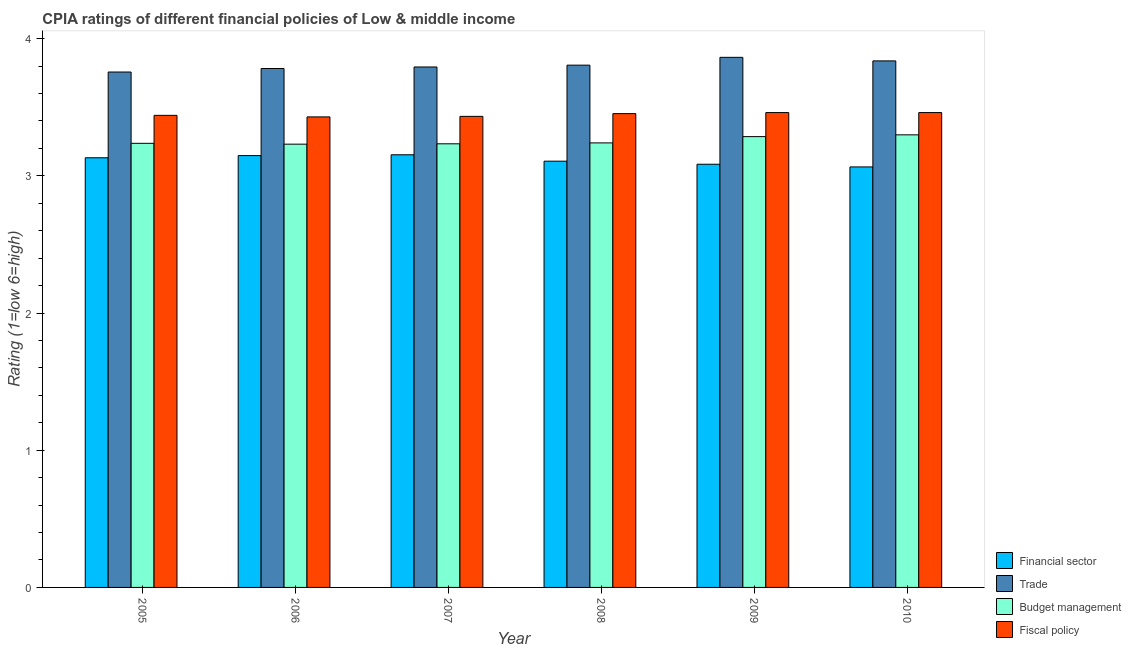How many groups of bars are there?
Keep it short and to the point. 6. How many bars are there on the 6th tick from the right?
Ensure brevity in your answer.  4. What is the cpia rating of fiscal policy in 2005?
Keep it short and to the point. 3.44. Across all years, what is the maximum cpia rating of trade?
Offer a terse response. 3.86. Across all years, what is the minimum cpia rating of budget management?
Keep it short and to the point. 3.23. In which year was the cpia rating of financial sector maximum?
Give a very brief answer. 2007. What is the total cpia rating of trade in the graph?
Your response must be concise. 22.84. What is the difference between the cpia rating of trade in 2005 and that in 2006?
Give a very brief answer. -0.03. What is the difference between the cpia rating of financial sector in 2005 and the cpia rating of trade in 2009?
Offer a terse response. 0.05. What is the average cpia rating of fiscal policy per year?
Give a very brief answer. 3.45. In how many years, is the cpia rating of fiscal policy greater than 0.8?
Give a very brief answer. 6. What is the ratio of the cpia rating of financial sector in 2005 to that in 2009?
Ensure brevity in your answer.  1.02. What is the difference between the highest and the second highest cpia rating of trade?
Your response must be concise. 0.03. What is the difference between the highest and the lowest cpia rating of trade?
Make the answer very short. 0.11. In how many years, is the cpia rating of financial sector greater than the average cpia rating of financial sector taken over all years?
Provide a short and direct response. 3. What does the 3rd bar from the left in 2008 represents?
Ensure brevity in your answer.  Budget management. What does the 2nd bar from the right in 2010 represents?
Your response must be concise. Budget management. Is it the case that in every year, the sum of the cpia rating of financial sector and cpia rating of trade is greater than the cpia rating of budget management?
Your answer should be compact. Yes. What is the difference between two consecutive major ticks on the Y-axis?
Offer a very short reply. 1. Are the values on the major ticks of Y-axis written in scientific E-notation?
Your answer should be very brief. No. Does the graph contain grids?
Give a very brief answer. No. Where does the legend appear in the graph?
Offer a very short reply. Bottom right. How many legend labels are there?
Your response must be concise. 4. What is the title of the graph?
Keep it short and to the point. CPIA ratings of different financial policies of Low & middle income. Does "Norway" appear as one of the legend labels in the graph?
Give a very brief answer. No. What is the Rating (1=low 6=high) in Financial sector in 2005?
Make the answer very short. 3.13. What is the Rating (1=low 6=high) in Trade in 2005?
Provide a succinct answer. 3.76. What is the Rating (1=low 6=high) of Budget management in 2005?
Keep it short and to the point. 3.24. What is the Rating (1=low 6=high) in Fiscal policy in 2005?
Give a very brief answer. 3.44. What is the Rating (1=low 6=high) of Financial sector in 2006?
Keep it short and to the point. 3.15. What is the Rating (1=low 6=high) in Trade in 2006?
Provide a short and direct response. 3.78. What is the Rating (1=low 6=high) in Budget management in 2006?
Provide a succinct answer. 3.23. What is the Rating (1=low 6=high) of Fiscal policy in 2006?
Ensure brevity in your answer.  3.43. What is the Rating (1=low 6=high) in Financial sector in 2007?
Provide a succinct answer. 3.15. What is the Rating (1=low 6=high) of Trade in 2007?
Keep it short and to the point. 3.79. What is the Rating (1=low 6=high) of Budget management in 2007?
Your answer should be compact. 3.23. What is the Rating (1=low 6=high) in Fiscal policy in 2007?
Offer a very short reply. 3.43. What is the Rating (1=low 6=high) in Financial sector in 2008?
Provide a succinct answer. 3.11. What is the Rating (1=low 6=high) in Trade in 2008?
Your answer should be compact. 3.81. What is the Rating (1=low 6=high) of Budget management in 2008?
Keep it short and to the point. 3.24. What is the Rating (1=low 6=high) of Fiscal policy in 2008?
Make the answer very short. 3.45. What is the Rating (1=low 6=high) of Financial sector in 2009?
Provide a succinct answer. 3.08. What is the Rating (1=low 6=high) in Trade in 2009?
Offer a very short reply. 3.86. What is the Rating (1=low 6=high) in Budget management in 2009?
Provide a succinct answer. 3.29. What is the Rating (1=low 6=high) of Fiscal policy in 2009?
Offer a very short reply. 3.46. What is the Rating (1=low 6=high) of Financial sector in 2010?
Ensure brevity in your answer.  3.06. What is the Rating (1=low 6=high) in Trade in 2010?
Offer a terse response. 3.84. What is the Rating (1=low 6=high) of Budget management in 2010?
Offer a very short reply. 3.3. What is the Rating (1=low 6=high) of Fiscal policy in 2010?
Ensure brevity in your answer.  3.46. Across all years, what is the maximum Rating (1=low 6=high) in Financial sector?
Make the answer very short. 3.15. Across all years, what is the maximum Rating (1=low 6=high) of Trade?
Give a very brief answer. 3.86. Across all years, what is the maximum Rating (1=low 6=high) of Budget management?
Keep it short and to the point. 3.3. Across all years, what is the maximum Rating (1=low 6=high) in Fiscal policy?
Provide a succinct answer. 3.46. Across all years, what is the minimum Rating (1=low 6=high) in Financial sector?
Give a very brief answer. 3.06. Across all years, what is the minimum Rating (1=low 6=high) in Trade?
Provide a short and direct response. 3.76. Across all years, what is the minimum Rating (1=low 6=high) of Budget management?
Provide a short and direct response. 3.23. Across all years, what is the minimum Rating (1=low 6=high) in Fiscal policy?
Your answer should be compact. 3.43. What is the total Rating (1=low 6=high) of Financial sector in the graph?
Make the answer very short. 18.69. What is the total Rating (1=low 6=high) in Trade in the graph?
Offer a terse response. 22.84. What is the total Rating (1=low 6=high) of Budget management in the graph?
Provide a succinct answer. 19.53. What is the total Rating (1=low 6=high) in Fiscal policy in the graph?
Give a very brief answer. 20.68. What is the difference between the Rating (1=low 6=high) of Financial sector in 2005 and that in 2006?
Make the answer very short. -0.02. What is the difference between the Rating (1=low 6=high) in Trade in 2005 and that in 2006?
Keep it short and to the point. -0.03. What is the difference between the Rating (1=low 6=high) in Budget management in 2005 and that in 2006?
Offer a terse response. 0.01. What is the difference between the Rating (1=low 6=high) in Fiscal policy in 2005 and that in 2006?
Ensure brevity in your answer.  0.01. What is the difference between the Rating (1=low 6=high) in Financial sector in 2005 and that in 2007?
Make the answer very short. -0.02. What is the difference between the Rating (1=low 6=high) of Trade in 2005 and that in 2007?
Offer a very short reply. -0.04. What is the difference between the Rating (1=low 6=high) of Budget management in 2005 and that in 2007?
Offer a very short reply. 0. What is the difference between the Rating (1=low 6=high) in Fiscal policy in 2005 and that in 2007?
Offer a terse response. 0.01. What is the difference between the Rating (1=low 6=high) of Financial sector in 2005 and that in 2008?
Your answer should be very brief. 0.02. What is the difference between the Rating (1=low 6=high) in Trade in 2005 and that in 2008?
Provide a short and direct response. -0.05. What is the difference between the Rating (1=low 6=high) in Budget management in 2005 and that in 2008?
Provide a succinct answer. -0. What is the difference between the Rating (1=low 6=high) in Fiscal policy in 2005 and that in 2008?
Ensure brevity in your answer.  -0.01. What is the difference between the Rating (1=low 6=high) in Financial sector in 2005 and that in 2009?
Offer a terse response. 0.05. What is the difference between the Rating (1=low 6=high) in Trade in 2005 and that in 2009?
Keep it short and to the point. -0.11. What is the difference between the Rating (1=low 6=high) in Budget management in 2005 and that in 2009?
Offer a very short reply. -0.05. What is the difference between the Rating (1=low 6=high) in Fiscal policy in 2005 and that in 2009?
Make the answer very short. -0.02. What is the difference between the Rating (1=low 6=high) in Financial sector in 2005 and that in 2010?
Provide a succinct answer. 0.07. What is the difference between the Rating (1=low 6=high) of Trade in 2005 and that in 2010?
Your answer should be compact. -0.08. What is the difference between the Rating (1=low 6=high) in Budget management in 2005 and that in 2010?
Offer a very short reply. -0.06. What is the difference between the Rating (1=low 6=high) in Fiscal policy in 2005 and that in 2010?
Your answer should be compact. -0.02. What is the difference between the Rating (1=low 6=high) in Financial sector in 2006 and that in 2007?
Your answer should be very brief. -0.01. What is the difference between the Rating (1=low 6=high) in Trade in 2006 and that in 2007?
Make the answer very short. -0.01. What is the difference between the Rating (1=low 6=high) in Budget management in 2006 and that in 2007?
Give a very brief answer. -0. What is the difference between the Rating (1=low 6=high) of Fiscal policy in 2006 and that in 2007?
Provide a short and direct response. -0. What is the difference between the Rating (1=low 6=high) in Financial sector in 2006 and that in 2008?
Offer a very short reply. 0.04. What is the difference between the Rating (1=low 6=high) of Trade in 2006 and that in 2008?
Give a very brief answer. -0.02. What is the difference between the Rating (1=low 6=high) in Budget management in 2006 and that in 2008?
Keep it short and to the point. -0.01. What is the difference between the Rating (1=low 6=high) in Fiscal policy in 2006 and that in 2008?
Provide a short and direct response. -0.02. What is the difference between the Rating (1=low 6=high) of Financial sector in 2006 and that in 2009?
Provide a succinct answer. 0.06. What is the difference between the Rating (1=low 6=high) of Trade in 2006 and that in 2009?
Give a very brief answer. -0.08. What is the difference between the Rating (1=low 6=high) in Budget management in 2006 and that in 2009?
Offer a terse response. -0.05. What is the difference between the Rating (1=low 6=high) of Fiscal policy in 2006 and that in 2009?
Ensure brevity in your answer.  -0.03. What is the difference between the Rating (1=low 6=high) of Financial sector in 2006 and that in 2010?
Provide a succinct answer. 0.08. What is the difference between the Rating (1=low 6=high) of Trade in 2006 and that in 2010?
Offer a very short reply. -0.06. What is the difference between the Rating (1=low 6=high) in Budget management in 2006 and that in 2010?
Your response must be concise. -0.07. What is the difference between the Rating (1=low 6=high) of Fiscal policy in 2006 and that in 2010?
Make the answer very short. -0.03. What is the difference between the Rating (1=low 6=high) of Financial sector in 2007 and that in 2008?
Your response must be concise. 0.05. What is the difference between the Rating (1=low 6=high) in Trade in 2007 and that in 2008?
Provide a short and direct response. -0.01. What is the difference between the Rating (1=low 6=high) of Budget management in 2007 and that in 2008?
Your response must be concise. -0.01. What is the difference between the Rating (1=low 6=high) of Fiscal policy in 2007 and that in 2008?
Offer a terse response. -0.02. What is the difference between the Rating (1=low 6=high) in Financial sector in 2007 and that in 2009?
Provide a succinct answer. 0.07. What is the difference between the Rating (1=low 6=high) of Trade in 2007 and that in 2009?
Offer a very short reply. -0.07. What is the difference between the Rating (1=low 6=high) of Budget management in 2007 and that in 2009?
Give a very brief answer. -0.05. What is the difference between the Rating (1=low 6=high) in Fiscal policy in 2007 and that in 2009?
Your answer should be compact. -0.03. What is the difference between the Rating (1=low 6=high) of Financial sector in 2007 and that in 2010?
Ensure brevity in your answer.  0.09. What is the difference between the Rating (1=low 6=high) of Trade in 2007 and that in 2010?
Provide a succinct answer. -0.04. What is the difference between the Rating (1=low 6=high) in Budget management in 2007 and that in 2010?
Your answer should be compact. -0.07. What is the difference between the Rating (1=low 6=high) of Fiscal policy in 2007 and that in 2010?
Provide a succinct answer. -0.03. What is the difference between the Rating (1=low 6=high) in Financial sector in 2008 and that in 2009?
Offer a very short reply. 0.02. What is the difference between the Rating (1=low 6=high) in Trade in 2008 and that in 2009?
Give a very brief answer. -0.06. What is the difference between the Rating (1=low 6=high) in Budget management in 2008 and that in 2009?
Give a very brief answer. -0.05. What is the difference between the Rating (1=low 6=high) in Fiscal policy in 2008 and that in 2009?
Ensure brevity in your answer.  -0.01. What is the difference between the Rating (1=low 6=high) in Financial sector in 2008 and that in 2010?
Keep it short and to the point. 0.04. What is the difference between the Rating (1=low 6=high) of Trade in 2008 and that in 2010?
Offer a terse response. -0.03. What is the difference between the Rating (1=low 6=high) of Budget management in 2008 and that in 2010?
Provide a short and direct response. -0.06. What is the difference between the Rating (1=low 6=high) in Fiscal policy in 2008 and that in 2010?
Ensure brevity in your answer.  -0.01. What is the difference between the Rating (1=low 6=high) of Financial sector in 2009 and that in 2010?
Provide a succinct answer. 0.02. What is the difference between the Rating (1=low 6=high) in Trade in 2009 and that in 2010?
Make the answer very short. 0.03. What is the difference between the Rating (1=low 6=high) of Budget management in 2009 and that in 2010?
Your response must be concise. -0.01. What is the difference between the Rating (1=low 6=high) of Financial sector in 2005 and the Rating (1=low 6=high) of Trade in 2006?
Your answer should be compact. -0.65. What is the difference between the Rating (1=low 6=high) in Financial sector in 2005 and the Rating (1=low 6=high) in Budget management in 2006?
Ensure brevity in your answer.  -0.1. What is the difference between the Rating (1=low 6=high) of Financial sector in 2005 and the Rating (1=low 6=high) of Fiscal policy in 2006?
Your answer should be compact. -0.3. What is the difference between the Rating (1=low 6=high) in Trade in 2005 and the Rating (1=low 6=high) in Budget management in 2006?
Ensure brevity in your answer.  0.53. What is the difference between the Rating (1=low 6=high) in Trade in 2005 and the Rating (1=low 6=high) in Fiscal policy in 2006?
Your answer should be very brief. 0.33. What is the difference between the Rating (1=low 6=high) of Budget management in 2005 and the Rating (1=low 6=high) of Fiscal policy in 2006?
Your answer should be compact. -0.19. What is the difference between the Rating (1=low 6=high) of Financial sector in 2005 and the Rating (1=low 6=high) of Trade in 2007?
Your response must be concise. -0.66. What is the difference between the Rating (1=low 6=high) of Financial sector in 2005 and the Rating (1=low 6=high) of Budget management in 2007?
Provide a short and direct response. -0.1. What is the difference between the Rating (1=low 6=high) in Financial sector in 2005 and the Rating (1=low 6=high) in Fiscal policy in 2007?
Ensure brevity in your answer.  -0.3. What is the difference between the Rating (1=low 6=high) in Trade in 2005 and the Rating (1=low 6=high) in Budget management in 2007?
Keep it short and to the point. 0.52. What is the difference between the Rating (1=low 6=high) in Trade in 2005 and the Rating (1=low 6=high) in Fiscal policy in 2007?
Offer a very short reply. 0.32. What is the difference between the Rating (1=low 6=high) of Budget management in 2005 and the Rating (1=low 6=high) of Fiscal policy in 2007?
Make the answer very short. -0.2. What is the difference between the Rating (1=low 6=high) of Financial sector in 2005 and the Rating (1=low 6=high) of Trade in 2008?
Provide a succinct answer. -0.68. What is the difference between the Rating (1=low 6=high) in Financial sector in 2005 and the Rating (1=low 6=high) in Budget management in 2008?
Make the answer very short. -0.11. What is the difference between the Rating (1=low 6=high) of Financial sector in 2005 and the Rating (1=low 6=high) of Fiscal policy in 2008?
Your answer should be compact. -0.32. What is the difference between the Rating (1=low 6=high) in Trade in 2005 and the Rating (1=low 6=high) in Budget management in 2008?
Ensure brevity in your answer.  0.52. What is the difference between the Rating (1=low 6=high) in Trade in 2005 and the Rating (1=low 6=high) in Fiscal policy in 2008?
Your answer should be compact. 0.3. What is the difference between the Rating (1=low 6=high) of Budget management in 2005 and the Rating (1=low 6=high) of Fiscal policy in 2008?
Ensure brevity in your answer.  -0.22. What is the difference between the Rating (1=low 6=high) in Financial sector in 2005 and the Rating (1=low 6=high) in Trade in 2009?
Offer a terse response. -0.73. What is the difference between the Rating (1=low 6=high) of Financial sector in 2005 and the Rating (1=low 6=high) of Budget management in 2009?
Provide a short and direct response. -0.15. What is the difference between the Rating (1=low 6=high) of Financial sector in 2005 and the Rating (1=low 6=high) of Fiscal policy in 2009?
Keep it short and to the point. -0.33. What is the difference between the Rating (1=low 6=high) of Trade in 2005 and the Rating (1=low 6=high) of Budget management in 2009?
Your response must be concise. 0.47. What is the difference between the Rating (1=low 6=high) in Trade in 2005 and the Rating (1=low 6=high) in Fiscal policy in 2009?
Keep it short and to the point. 0.3. What is the difference between the Rating (1=low 6=high) of Budget management in 2005 and the Rating (1=low 6=high) of Fiscal policy in 2009?
Keep it short and to the point. -0.22. What is the difference between the Rating (1=low 6=high) of Financial sector in 2005 and the Rating (1=low 6=high) of Trade in 2010?
Your answer should be very brief. -0.71. What is the difference between the Rating (1=low 6=high) in Financial sector in 2005 and the Rating (1=low 6=high) in Budget management in 2010?
Offer a terse response. -0.17. What is the difference between the Rating (1=low 6=high) of Financial sector in 2005 and the Rating (1=low 6=high) of Fiscal policy in 2010?
Your answer should be very brief. -0.33. What is the difference between the Rating (1=low 6=high) of Trade in 2005 and the Rating (1=low 6=high) of Budget management in 2010?
Your response must be concise. 0.46. What is the difference between the Rating (1=low 6=high) in Trade in 2005 and the Rating (1=low 6=high) in Fiscal policy in 2010?
Offer a terse response. 0.3. What is the difference between the Rating (1=low 6=high) in Budget management in 2005 and the Rating (1=low 6=high) in Fiscal policy in 2010?
Your response must be concise. -0.22. What is the difference between the Rating (1=low 6=high) of Financial sector in 2006 and the Rating (1=low 6=high) of Trade in 2007?
Offer a terse response. -0.65. What is the difference between the Rating (1=low 6=high) in Financial sector in 2006 and the Rating (1=low 6=high) in Budget management in 2007?
Provide a short and direct response. -0.09. What is the difference between the Rating (1=low 6=high) of Financial sector in 2006 and the Rating (1=low 6=high) of Fiscal policy in 2007?
Ensure brevity in your answer.  -0.29. What is the difference between the Rating (1=low 6=high) in Trade in 2006 and the Rating (1=low 6=high) in Budget management in 2007?
Keep it short and to the point. 0.55. What is the difference between the Rating (1=low 6=high) in Trade in 2006 and the Rating (1=low 6=high) in Fiscal policy in 2007?
Make the answer very short. 0.35. What is the difference between the Rating (1=low 6=high) in Budget management in 2006 and the Rating (1=low 6=high) in Fiscal policy in 2007?
Provide a short and direct response. -0.2. What is the difference between the Rating (1=low 6=high) of Financial sector in 2006 and the Rating (1=low 6=high) of Trade in 2008?
Your answer should be very brief. -0.66. What is the difference between the Rating (1=low 6=high) in Financial sector in 2006 and the Rating (1=low 6=high) in Budget management in 2008?
Offer a terse response. -0.09. What is the difference between the Rating (1=low 6=high) in Financial sector in 2006 and the Rating (1=low 6=high) in Fiscal policy in 2008?
Keep it short and to the point. -0.31. What is the difference between the Rating (1=low 6=high) of Trade in 2006 and the Rating (1=low 6=high) of Budget management in 2008?
Offer a terse response. 0.54. What is the difference between the Rating (1=low 6=high) in Trade in 2006 and the Rating (1=low 6=high) in Fiscal policy in 2008?
Give a very brief answer. 0.33. What is the difference between the Rating (1=low 6=high) of Budget management in 2006 and the Rating (1=low 6=high) of Fiscal policy in 2008?
Your answer should be compact. -0.22. What is the difference between the Rating (1=low 6=high) of Financial sector in 2006 and the Rating (1=low 6=high) of Trade in 2009?
Your response must be concise. -0.72. What is the difference between the Rating (1=low 6=high) of Financial sector in 2006 and the Rating (1=low 6=high) of Budget management in 2009?
Keep it short and to the point. -0.14. What is the difference between the Rating (1=low 6=high) in Financial sector in 2006 and the Rating (1=low 6=high) in Fiscal policy in 2009?
Offer a terse response. -0.31. What is the difference between the Rating (1=low 6=high) of Trade in 2006 and the Rating (1=low 6=high) of Budget management in 2009?
Ensure brevity in your answer.  0.5. What is the difference between the Rating (1=low 6=high) of Trade in 2006 and the Rating (1=low 6=high) of Fiscal policy in 2009?
Ensure brevity in your answer.  0.32. What is the difference between the Rating (1=low 6=high) in Budget management in 2006 and the Rating (1=low 6=high) in Fiscal policy in 2009?
Provide a succinct answer. -0.23. What is the difference between the Rating (1=low 6=high) in Financial sector in 2006 and the Rating (1=low 6=high) in Trade in 2010?
Your answer should be compact. -0.69. What is the difference between the Rating (1=low 6=high) of Financial sector in 2006 and the Rating (1=low 6=high) of Budget management in 2010?
Ensure brevity in your answer.  -0.15. What is the difference between the Rating (1=low 6=high) in Financial sector in 2006 and the Rating (1=low 6=high) in Fiscal policy in 2010?
Your answer should be very brief. -0.31. What is the difference between the Rating (1=low 6=high) of Trade in 2006 and the Rating (1=low 6=high) of Budget management in 2010?
Ensure brevity in your answer.  0.48. What is the difference between the Rating (1=low 6=high) in Trade in 2006 and the Rating (1=low 6=high) in Fiscal policy in 2010?
Provide a succinct answer. 0.32. What is the difference between the Rating (1=low 6=high) in Budget management in 2006 and the Rating (1=low 6=high) in Fiscal policy in 2010?
Give a very brief answer. -0.23. What is the difference between the Rating (1=low 6=high) of Financial sector in 2007 and the Rating (1=low 6=high) of Trade in 2008?
Provide a succinct answer. -0.65. What is the difference between the Rating (1=low 6=high) of Financial sector in 2007 and the Rating (1=low 6=high) of Budget management in 2008?
Keep it short and to the point. -0.09. What is the difference between the Rating (1=low 6=high) of Trade in 2007 and the Rating (1=low 6=high) of Budget management in 2008?
Provide a short and direct response. 0.55. What is the difference between the Rating (1=low 6=high) in Trade in 2007 and the Rating (1=low 6=high) in Fiscal policy in 2008?
Make the answer very short. 0.34. What is the difference between the Rating (1=low 6=high) in Budget management in 2007 and the Rating (1=low 6=high) in Fiscal policy in 2008?
Your response must be concise. -0.22. What is the difference between the Rating (1=low 6=high) in Financial sector in 2007 and the Rating (1=low 6=high) in Trade in 2009?
Your answer should be very brief. -0.71. What is the difference between the Rating (1=low 6=high) of Financial sector in 2007 and the Rating (1=low 6=high) of Budget management in 2009?
Give a very brief answer. -0.13. What is the difference between the Rating (1=low 6=high) in Financial sector in 2007 and the Rating (1=low 6=high) in Fiscal policy in 2009?
Offer a very short reply. -0.31. What is the difference between the Rating (1=low 6=high) in Trade in 2007 and the Rating (1=low 6=high) in Budget management in 2009?
Give a very brief answer. 0.51. What is the difference between the Rating (1=low 6=high) in Trade in 2007 and the Rating (1=low 6=high) in Fiscal policy in 2009?
Offer a very short reply. 0.33. What is the difference between the Rating (1=low 6=high) of Budget management in 2007 and the Rating (1=low 6=high) of Fiscal policy in 2009?
Your answer should be very brief. -0.23. What is the difference between the Rating (1=low 6=high) of Financial sector in 2007 and the Rating (1=low 6=high) of Trade in 2010?
Your response must be concise. -0.68. What is the difference between the Rating (1=low 6=high) in Financial sector in 2007 and the Rating (1=low 6=high) in Budget management in 2010?
Your answer should be very brief. -0.15. What is the difference between the Rating (1=low 6=high) of Financial sector in 2007 and the Rating (1=low 6=high) of Fiscal policy in 2010?
Your response must be concise. -0.31. What is the difference between the Rating (1=low 6=high) of Trade in 2007 and the Rating (1=low 6=high) of Budget management in 2010?
Provide a succinct answer. 0.49. What is the difference between the Rating (1=low 6=high) of Trade in 2007 and the Rating (1=low 6=high) of Fiscal policy in 2010?
Your answer should be very brief. 0.33. What is the difference between the Rating (1=low 6=high) in Budget management in 2007 and the Rating (1=low 6=high) in Fiscal policy in 2010?
Offer a terse response. -0.23. What is the difference between the Rating (1=low 6=high) in Financial sector in 2008 and the Rating (1=low 6=high) in Trade in 2009?
Provide a succinct answer. -0.76. What is the difference between the Rating (1=low 6=high) of Financial sector in 2008 and the Rating (1=low 6=high) of Budget management in 2009?
Your response must be concise. -0.18. What is the difference between the Rating (1=low 6=high) in Financial sector in 2008 and the Rating (1=low 6=high) in Fiscal policy in 2009?
Make the answer very short. -0.35. What is the difference between the Rating (1=low 6=high) in Trade in 2008 and the Rating (1=low 6=high) in Budget management in 2009?
Provide a succinct answer. 0.52. What is the difference between the Rating (1=low 6=high) of Trade in 2008 and the Rating (1=low 6=high) of Fiscal policy in 2009?
Your answer should be very brief. 0.35. What is the difference between the Rating (1=low 6=high) of Budget management in 2008 and the Rating (1=low 6=high) of Fiscal policy in 2009?
Your answer should be compact. -0.22. What is the difference between the Rating (1=low 6=high) in Financial sector in 2008 and the Rating (1=low 6=high) in Trade in 2010?
Provide a short and direct response. -0.73. What is the difference between the Rating (1=low 6=high) in Financial sector in 2008 and the Rating (1=low 6=high) in Budget management in 2010?
Provide a short and direct response. -0.19. What is the difference between the Rating (1=low 6=high) in Financial sector in 2008 and the Rating (1=low 6=high) in Fiscal policy in 2010?
Your answer should be very brief. -0.35. What is the difference between the Rating (1=low 6=high) in Trade in 2008 and the Rating (1=low 6=high) in Budget management in 2010?
Offer a terse response. 0.51. What is the difference between the Rating (1=low 6=high) in Trade in 2008 and the Rating (1=low 6=high) in Fiscal policy in 2010?
Provide a succinct answer. 0.35. What is the difference between the Rating (1=low 6=high) of Budget management in 2008 and the Rating (1=low 6=high) of Fiscal policy in 2010?
Your answer should be very brief. -0.22. What is the difference between the Rating (1=low 6=high) in Financial sector in 2009 and the Rating (1=low 6=high) in Trade in 2010?
Give a very brief answer. -0.75. What is the difference between the Rating (1=low 6=high) in Financial sector in 2009 and the Rating (1=low 6=high) in Budget management in 2010?
Provide a succinct answer. -0.21. What is the difference between the Rating (1=low 6=high) in Financial sector in 2009 and the Rating (1=low 6=high) in Fiscal policy in 2010?
Provide a short and direct response. -0.38. What is the difference between the Rating (1=low 6=high) in Trade in 2009 and the Rating (1=low 6=high) in Budget management in 2010?
Your answer should be very brief. 0.56. What is the difference between the Rating (1=low 6=high) in Trade in 2009 and the Rating (1=low 6=high) in Fiscal policy in 2010?
Offer a very short reply. 0.4. What is the difference between the Rating (1=low 6=high) of Budget management in 2009 and the Rating (1=low 6=high) of Fiscal policy in 2010?
Provide a succinct answer. -0.18. What is the average Rating (1=low 6=high) in Financial sector per year?
Provide a succinct answer. 3.11. What is the average Rating (1=low 6=high) of Trade per year?
Your answer should be very brief. 3.81. What is the average Rating (1=low 6=high) of Budget management per year?
Offer a terse response. 3.25. What is the average Rating (1=low 6=high) in Fiscal policy per year?
Offer a terse response. 3.45. In the year 2005, what is the difference between the Rating (1=low 6=high) in Financial sector and Rating (1=low 6=high) in Trade?
Provide a short and direct response. -0.62. In the year 2005, what is the difference between the Rating (1=low 6=high) in Financial sector and Rating (1=low 6=high) in Budget management?
Make the answer very short. -0.11. In the year 2005, what is the difference between the Rating (1=low 6=high) in Financial sector and Rating (1=low 6=high) in Fiscal policy?
Your answer should be compact. -0.31. In the year 2005, what is the difference between the Rating (1=low 6=high) of Trade and Rating (1=low 6=high) of Budget management?
Your answer should be very brief. 0.52. In the year 2005, what is the difference between the Rating (1=low 6=high) of Trade and Rating (1=low 6=high) of Fiscal policy?
Ensure brevity in your answer.  0.32. In the year 2005, what is the difference between the Rating (1=low 6=high) in Budget management and Rating (1=low 6=high) in Fiscal policy?
Ensure brevity in your answer.  -0.2. In the year 2006, what is the difference between the Rating (1=low 6=high) of Financial sector and Rating (1=low 6=high) of Trade?
Offer a very short reply. -0.63. In the year 2006, what is the difference between the Rating (1=low 6=high) in Financial sector and Rating (1=low 6=high) in Budget management?
Ensure brevity in your answer.  -0.08. In the year 2006, what is the difference between the Rating (1=low 6=high) in Financial sector and Rating (1=low 6=high) in Fiscal policy?
Make the answer very short. -0.28. In the year 2006, what is the difference between the Rating (1=low 6=high) in Trade and Rating (1=low 6=high) in Budget management?
Offer a terse response. 0.55. In the year 2006, what is the difference between the Rating (1=low 6=high) in Trade and Rating (1=low 6=high) in Fiscal policy?
Provide a succinct answer. 0.35. In the year 2006, what is the difference between the Rating (1=low 6=high) of Budget management and Rating (1=low 6=high) of Fiscal policy?
Your answer should be compact. -0.2. In the year 2007, what is the difference between the Rating (1=low 6=high) of Financial sector and Rating (1=low 6=high) of Trade?
Your answer should be very brief. -0.64. In the year 2007, what is the difference between the Rating (1=low 6=high) of Financial sector and Rating (1=low 6=high) of Budget management?
Provide a succinct answer. -0.08. In the year 2007, what is the difference between the Rating (1=low 6=high) in Financial sector and Rating (1=low 6=high) in Fiscal policy?
Offer a terse response. -0.28. In the year 2007, what is the difference between the Rating (1=low 6=high) in Trade and Rating (1=low 6=high) in Budget management?
Offer a very short reply. 0.56. In the year 2007, what is the difference between the Rating (1=low 6=high) in Trade and Rating (1=low 6=high) in Fiscal policy?
Make the answer very short. 0.36. In the year 2007, what is the difference between the Rating (1=low 6=high) in Budget management and Rating (1=low 6=high) in Fiscal policy?
Ensure brevity in your answer.  -0.2. In the year 2008, what is the difference between the Rating (1=low 6=high) in Financial sector and Rating (1=low 6=high) in Budget management?
Your answer should be very brief. -0.13. In the year 2008, what is the difference between the Rating (1=low 6=high) of Financial sector and Rating (1=low 6=high) of Fiscal policy?
Provide a short and direct response. -0.35. In the year 2008, what is the difference between the Rating (1=low 6=high) in Trade and Rating (1=low 6=high) in Budget management?
Give a very brief answer. 0.57. In the year 2008, what is the difference between the Rating (1=low 6=high) in Trade and Rating (1=low 6=high) in Fiscal policy?
Provide a succinct answer. 0.35. In the year 2008, what is the difference between the Rating (1=low 6=high) in Budget management and Rating (1=low 6=high) in Fiscal policy?
Keep it short and to the point. -0.21. In the year 2009, what is the difference between the Rating (1=low 6=high) in Financial sector and Rating (1=low 6=high) in Trade?
Ensure brevity in your answer.  -0.78. In the year 2009, what is the difference between the Rating (1=low 6=high) in Financial sector and Rating (1=low 6=high) in Budget management?
Keep it short and to the point. -0.2. In the year 2009, what is the difference between the Rating (1=low 6=high) of Financial sector and Rating (1=low 6=high) of Fiscal policy?
Your answer should be compact. -0.38. In the year 2009, what is the difference between the Rating (1=low 6=high) of Trade and Rating (1=low 6=high) of Budget management?
Ensure brevity in your answer.  0.58. In the year 2009, what is the difference between the Rating (1=low 6=high) of Trade and Rating (1=low 6=high) of Fiscal policy?
Give a very brief answer. 0.4. In the year 2009, what is the difference between the Rating (1=low 6=high) of Budget management and Rating (1=low 6=high) of Fiscal policy?
Ensure brevity in your answer.  -0.18. In the year 2010, what is the difference between the Rating (1=low 6=high) in Financial sector and Rating (1=low 6=high) in Trade?
Your answer should be compact. -0.77. In the year 2010, what is the difference between the Rating (1=low 6=high) of Financial sector and Rating (1=low 6=high) of Budget management?
Your answer should be compact. -0.23. In the year 2010, what is the difference between the Rating (1=low 6=high) of Financial sector and Rating (1=low 6=high) of Fiscal policy?
Keep it short and to the point. -0.4. In the year 2010, what is the difference between the Rating (1=low 6=high) in Trade and Rating (1=low 6=high) in Budget management?
Keep it short and to the point. 0.54. In the year 2010, what is the difference between the Rating (1=low 6=high) of Trade and Rating (1=low 6=high) of Fiscal policy?
Ensure brevity in your answer.  0.38. In the year 2010, what is the difference between the Rating (1=low 6=high) of Budget management and Rating (1=low 6=high) of Fiscal policy?
Give a very brief answer. -0.16. What is the ratio of the Rating (1=low 6=high) in Financial sector in 2005 to that in 2006?
Provide a short and direct response. 0.99. What is the ratio of the Rating (1=low 6=high) in Trade in 2005 to that in 2006?
Offer a terse response. 0.99. What is the ratio of the Rating (1=low 6=high) of Budget management in 2005 to that in 2006?
Provide a succinct answer. 1. What is the ratio of the Rating (1=low 6=high) of Financial sector in 2005 to that in 2007?
Your response must be concise. 0.99. What is the ratio of the Rating (1=low 6=high) in Trade in 2005 to that in 2007?
Give a very brief answer. 0.99. What is the ratio of the Rating (1=low 6=high) in Financial sector in 2005 to that in 2008?
Your response must be concise. 1.01. What is the ratio of the Rating (1=low 6=high) in Trade in 2005 to that in 2008?
Keep it short and to the point. 0.99. What is the ratio of the Rating (1=low 6=high) in Budget management in 2005 to that in 2008?
Give a very brief answer. 1. What is the ratio of the Rating (1=low 6=high) of Financial sector in 2005 to that in 2009?
Offer a terse response. 1.02. What is the ratio of the Rating (1=low 6=high) of Trade in 2005 to that in 2009?
Provide a succinct answer. 0.97. What is the ratio of the Rating (1=low 6=high) in Budget management in 2005 to that in 2009?
Ensure brevity in your answer.  0.99. What is the ratio of the Rating (1=low 6=high) in Fiscal policy in 2005 to that in 2009?
Give a very brief answer. 0.99. What is the ratio of the Rating (1=low 6=high) of Financial sector in 2005 to that in 2010?
Provide a short and direct response. 1.02. What is the ratio of the Rating (1=low 6=high) in Trade in 2005 to that in 2010?
Keep it short and to the point. 0.98. What is the ratio of the Rating (1=low 6=high) of Budget management in 2005 to that in 2010?
Keep it short and to the point. 0.98. What is the ratio of the Rating (1=low 6=high) of Financial sector in 2006 to that in 2007?
Keep it short and to the point. 1. What is the ratio of the Rating (1=low 6=high) of Trade in 2006 to that in 2007?
Offer a very short reply. 1. What is the ratio of the Rating (1=low 6=high) of Budget management in 2006 to that in 2007?
Give a very brief answer. 1. What is the ratio of the Rating (1=low 6=high) of Financial sector in 2006 to that in 2008?
Offer a terse response. 1.01. What is the ratio of the Rating (1=low 6=high) in Trade in 2006 to that in 2008?
Keep it short and to the point. 0.99. What is the ratio of the Rating (1=low 6=high) of Budget management in 2006 to that in 2008?
Ensure brevity in your answer.  1. What is the ratio of the Rating (1=low 6=high) of Financial sector in 2006 to that in 2009?
Keep it short and to the point. 1.02. What is the ratio of the Rating (1=low 6=high) of Trade in 2006 to that in 2009?
Provide a short and direct response. 0.98. What is the ratio of the Rating (1=low 6=high) in Budget management in 2006 to that in 2009?
Keep it short and to the point. 0.98. What is the ratio of the Rating (1=low 6=high) of Fiscal policy in 2006 to that in 2009?
Provide a short and direct response. 0.99. What is the ratio of the Rating (1=low 6=high) of Financial sector in 2006 to that in 2010?
Your response must be concise. 1.03. What is the ratio of the Rating (1=low 6=high) of Trade in 2006 to that in 2010?
Your answer should be compact. 0.99. What is the ratio of the Rating (1=low 6=high) of Budget management in 2006 to that in 2010?
Keep it short and to the point. 0.98. What is the ratio of the Rating (1=low 6=high) in Fiscal policy in 2006 to that in 2010?
Keep it short and to the point. 0.99. What is the ratio of the Rating (1=low 6=high) in Fiscal policy in 2007 to that in 2008?
Make the answer very short. 0.99. What is the ratio of the Rating (1=low 6=high) in Financial sector in 2007 to that in 2009?
Provide a succinct answer. 1.02. What is the ratio of the Rating (1=low 6=high) of Trade in 2007 to that in 2009?
Provide a short and direct response. 0.98. What is the ratio of the Rating (1=low 6=high) of Budget management in 2007 to that in 2009?
Your answer should be very brief. 0.98. What is the ratio of the Rating (1=low 6=high) of Financial sector in 2007 to that in 2010?
Provide a succinct answer. 1.03. What is the ratio of the Rating (1=low 6=high) in Trade in 2007 to that in 2010?
Give a very brief answer. 0.99. What is the ratio of the Rating (1=low 6=high) in Budget management in 2007 to that in 2010?
Keep it short and to the point. 0.98. What is the ratio of the Rating (1=low 6=high) of Fiscal policy in 2007 to that in 2010?
Ensure brevity in your answer.  0.99. What is the ratio of the Rating (1=low 6=high) of Financial sector in 2008 to that in 2009?
Give a very brief answer. 1.01. What is the ratio of the Rating (1=low 6=high) in Budget management in 2008 to that in 2009?
Your answer should be very brief. 0.99. What is the ratio of the Rating (1=low 6=high) in Fiscal policy in 2008 to that in 2009?
Keep it short and to the point. 1. What is the ratio of the Rating (1=low 6=high) in Financial sector in 2008 to that in 2010?
Your answer should be very brief. 1.01. What is the ratio of the Rating (1=low 6=high) of Trade in 2008 to that in 2010?
Ensure brevity in your answer.  0.99. What is the ratio of the Rating (1=low 6=high) of Budget management in 2008 to that in 2010?
Ensure brevity in your answer.  0.98. What is the ratio of the Rating (1=low 6=high) of Financial sector in 2009 to that in 2010?
Offer a terse response. 1.01. What is the ratio of the Rating (1=low 6=high) in Trade in 2009 to that in 2010?
Offer a terse response. 1.01. What is the ratio of the Rating (1=low 6=high) of Budget management in 2009 to that in 2010?
Keep it short and to the point. 1. What is the difference between the highest and the second highest Rating (1=low 6=high) in Financial sector?
Make the answer very short. 0.01. What is the difference between the highest and the second highest Rating (1=low 6=high) of Trade?
Your answer should be compact. 0.03. What is the difference between the highest and the second highest Rating (1=low 6=high) of Budget management?
Offer a terse response. 0.01. What is the difference between the highest and the second highest Rating (1=low 6=high) of Fiscal policy?
Ensure brevity in your answer.  0. What is the difference between the highest and the lowest Rating (1=low 6=high) in Financial sector?
Your response must be concise. 0.09. What is the difference between the highest and the lowest Rating (1=low 6=high) of Trade?
Provide a short and direct response. 0.11. What is the difference between the highest and the lowest Rating (1=low 6=high) in Budget management?
Provide a short and direct response. 0.07. What is the difference between the highest and the lowest Rating (1=low 6=high) of Fiscal policy?
Your response must be concise. 0.03. 